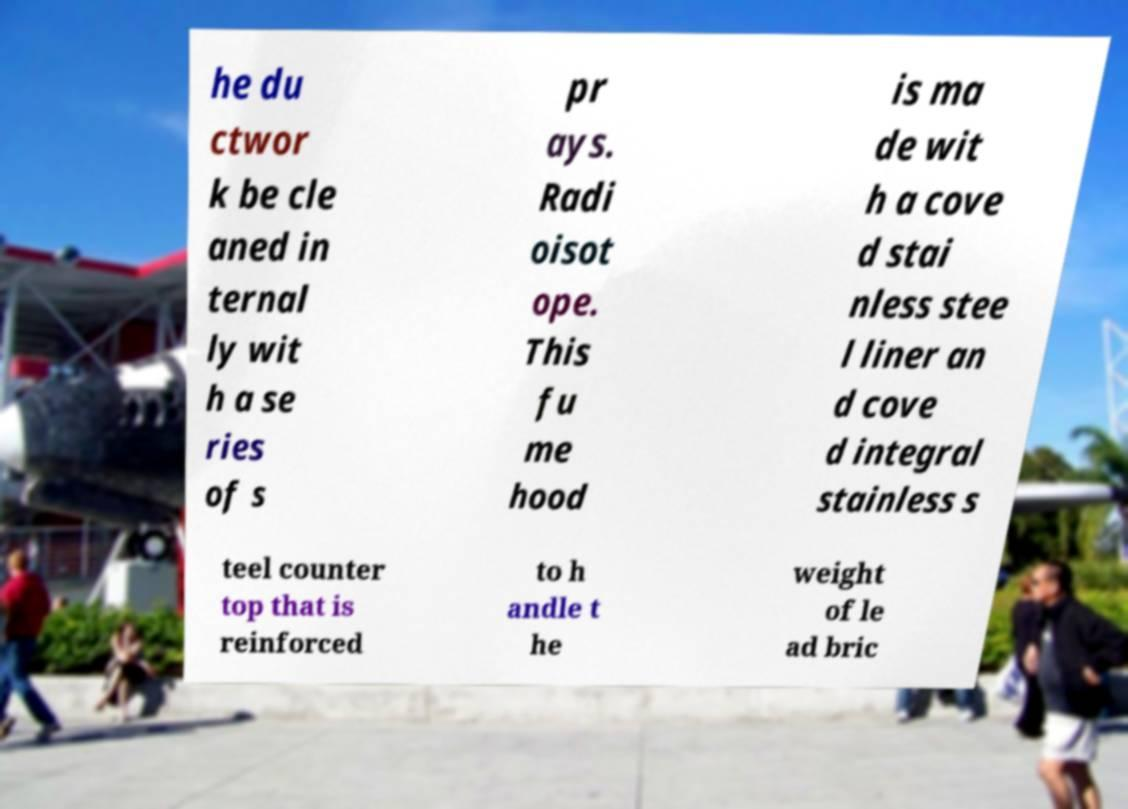Please identify and transcribe the text found in this image. he du ctwor k be cle aned in ternal ly wit h a se ries of s pr ays. Radi oisot ope. This fu me hood is ma de wit h a cove d stai nless stee l liner an d cove d integral stainless s teel counter top that is reinforced to h andle t he weight of le ad bric 